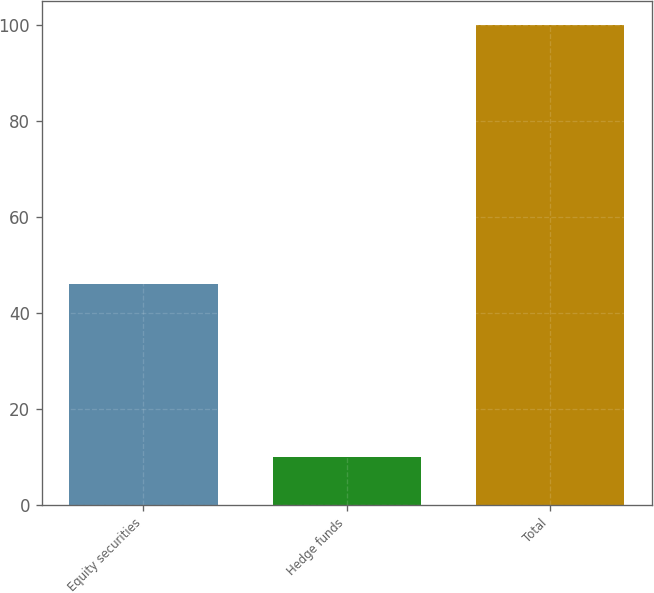Convert chart. <chart><loc_0><loc_0><loc_500><loc_500><bar_chart><fcel>Equity securities<fcel>Hedge funds<fcel>Total<nl><fcel>46<fcel>10<fcel>100<nl></chart> 